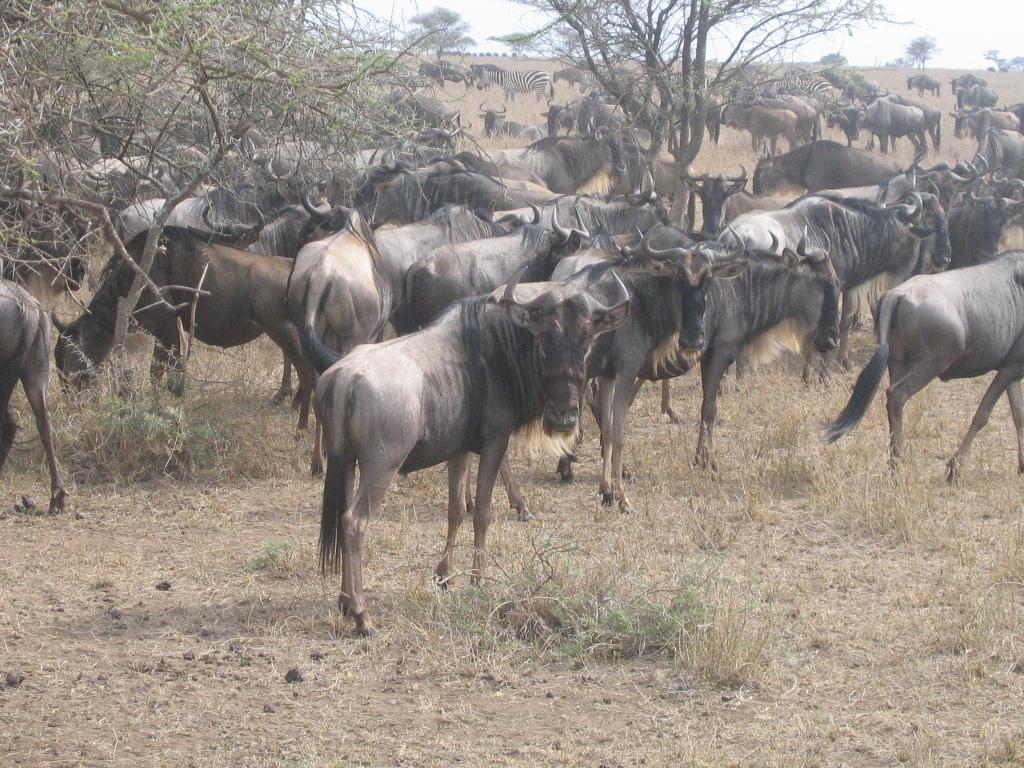Describe this image in one or two sentences. In the image there are many animals standing and grazing grass on the land with dry trees in the front and above its sky. 